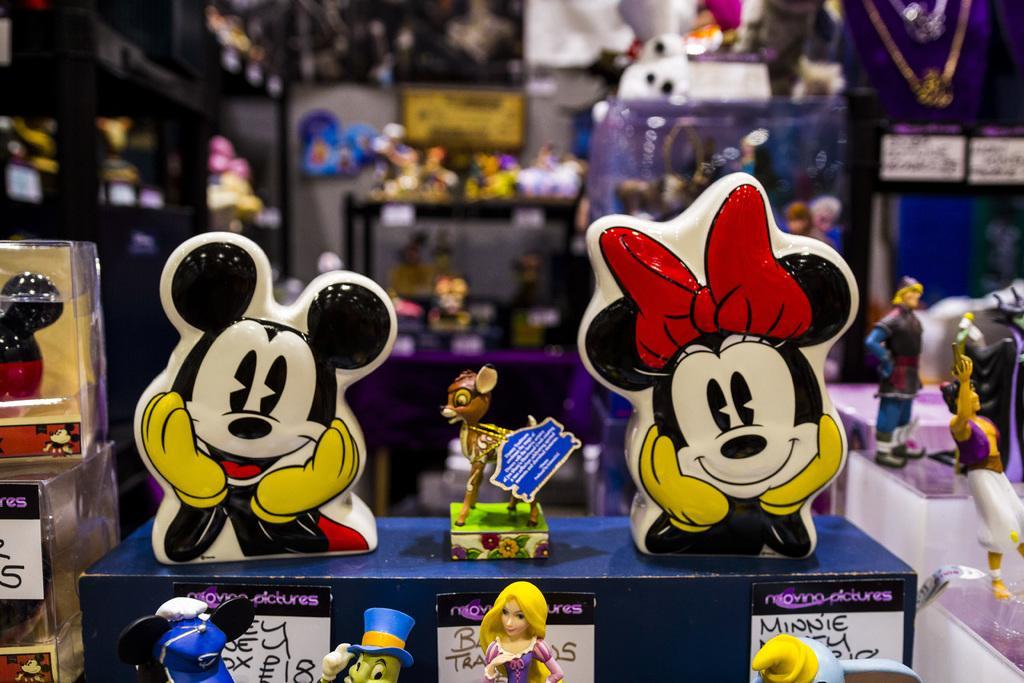Can you describe this image briefly? This picture shows store with toys and we see price boards fixed under the toys. 